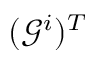<formula> <loc_0><loc_0><loc_500><loc_500>( \mathcal { G } ^ { i } ) ^ { T }</formula> 